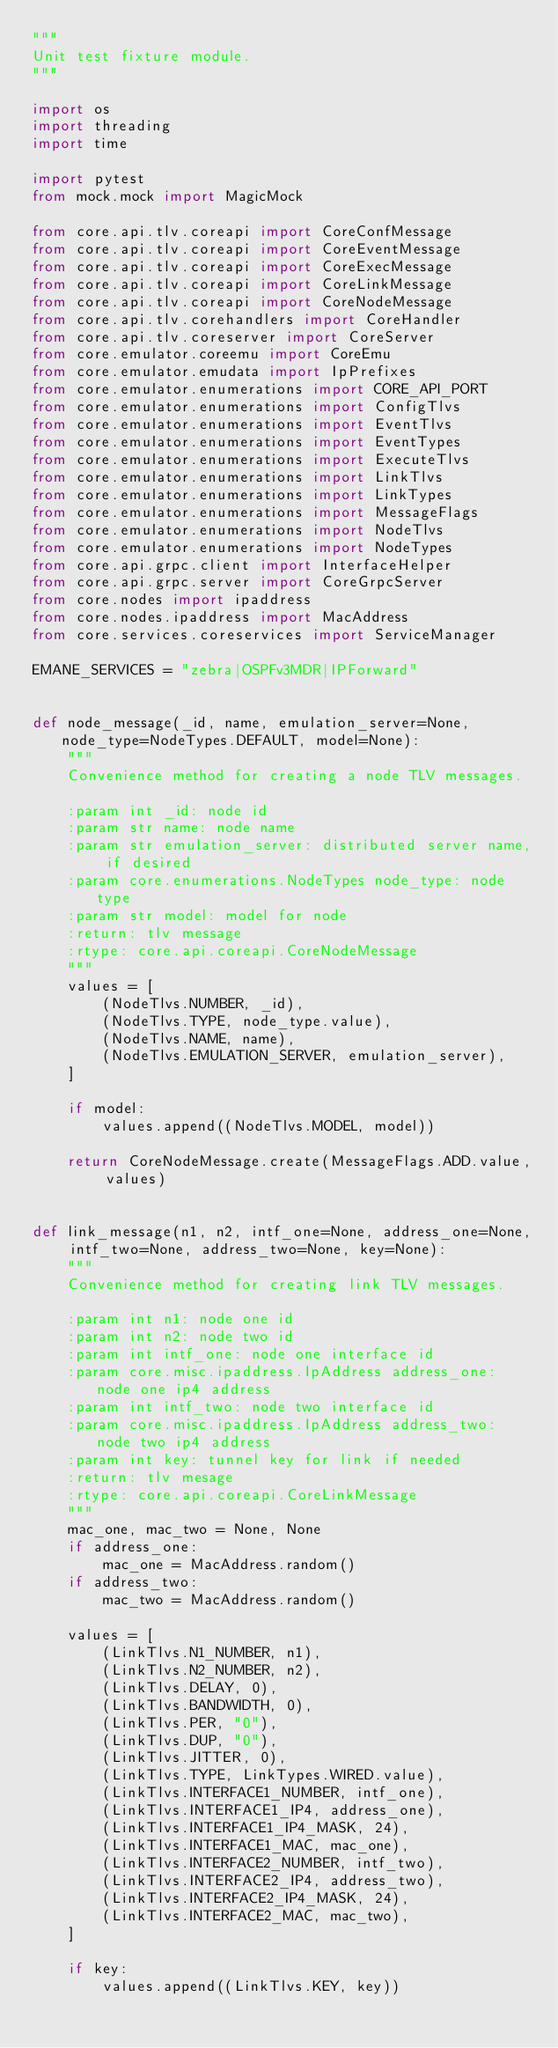<code> <loc_0><loc_0><loc_500><loc_500><_Python_>"""
Unit test fixture module.
"""

import os
import threading
import time

import pytest
from mock.mock import MagicMock

from core.api.tlv.coreapi import CoreConfMessage
from core.api.tlv.coreapi import CoreEventMessage
from core.api.tlv.coreapi import CoreExecMessage
from core.api.tlv.coreapi import CoreLinkMessage
from core.api.tlv.coreapi import CoreNodeMessage
from core.api.tlv.corehandlers import CoreHandler
from core.api.tlv.coreserver import CoreServer
from core.emulator.coreemu import CoreEmu
from core.emulator.emudata import IpPrefixes
from core.emulator.enumerations import CORE_API_PORT
from core.emulator.enumerations import ConfigTlvs
from core.emulator.enumerations import EventTlvs
from core.emulator.enumerations import EventTypes
from core.emulator.enumerations import ExecuteTlvs
from core.emulator.enumerations import LinkTlvs
from core.emulator.enumerations import LinkTypes
from core.emulator.enumerations import MessageFlags
from core.emulator.enumerations import NodeTlvs
from core.emulator.enumerations import NodeTypes
from core.api.grpc.client import InterfaceHelper
from core.api.grpc.server import CoreGrpcServer
from core.nodes import ipaddress
from core.nodes.ipaddress import MacAddress
from core.services.coreservices import ServiceManager

EMANE_SERVICES = "zebra|OSPFv3MDR|IPForward"


def node_message(_id, name, emulation_server=None, node_type=NodeTypes.DEFAULT, model=None):
    """
    Convenience method for creating a node TLV messages.

    :param int _id: node id
    :param str name: node name
    :param str emulation_server: distributed server name, if desired
    :param core.enumerations.NodeTypes node_type: node type
    :param str model: model for node
    :return: tlv message
    :rtype: core.api.coreapi.CoreNodeMessage
    """
    values = [
        (NodeTlvs.NUMBER, _id),
        (NodeTlvs.TYPE, node_type.value),
        (NodeTlvs.NAME, name),
        (NodeTlvs.EMULATION_SERVER, emulation_server),
    ]

    if model:
        values.append((NodeTlvs.MODEL, model))

    return CoreNodeMessage.create(MessageFlags.ADD.value, values)


def link_message(n1, n2, intf_one=None, address_one=None, intf_two=None, address_two=None, key=None):
    """
    Convenience method for creating link TLV messages.

    :param int n1: node one id
    :param int n2: node two id
    :param int intf_one: node one interface id
    :param core.misc.ipaddress.IpAddress address_one: node one ip4 address
    :param int intf_two: node two interface id
    :param core.misc.ipaddress.IpAddress address_two: node two ip4 address
    :param int key: tunnel key for link if needed
    :return: tlv mesage
    :rtype: core.api.coreapi.CoreLinkMessage
    """
    mac_one, mac_two = None, None
    if address_one:
        mac_one = MacAddress.random()
    if address_two:
        mac_two = MacAddress.random()

    values = [
        (LinkTlvs.N1_NUMBER, n1),
        (LinkTlvs.N2_NUMBER, n2),
        (LinkTlvs.DELAY, 0),
        (LinkTlvs.BANDWIDTH, 0),
        (LinkTlvs.PER, "0"),
        (LinkTlvs.DUP, "0"),
        (LinkTlvs.JITTER, 0),
        (LinkTlvs.TYPE, LinkTypes.WIRED.value),
        (LinkTlvs.INTERFACE1_NUMBER, intf_one),
        (LinkTlvs.INTERFACE1_IP4, address_one),
        (LinkTlvs.INTERFACE1_IP4_MASK, 24),
        (LinkTlvs.INTERFACE1_MAC, mac_one),
        (LinkTlvs.INTERFACE2_NUMBER, intf_two),
        (LinkTlvs.INTERFACE2_IP4, address_two),
        (LinkTlvs.INTERFACE2_IP4_MASK, 24),
        (LinkTlvs.INTERFACE2_MAC, mac_two),
    ]

    if key:
        values.append((LinkTlvs.KEY, key))
</code> 